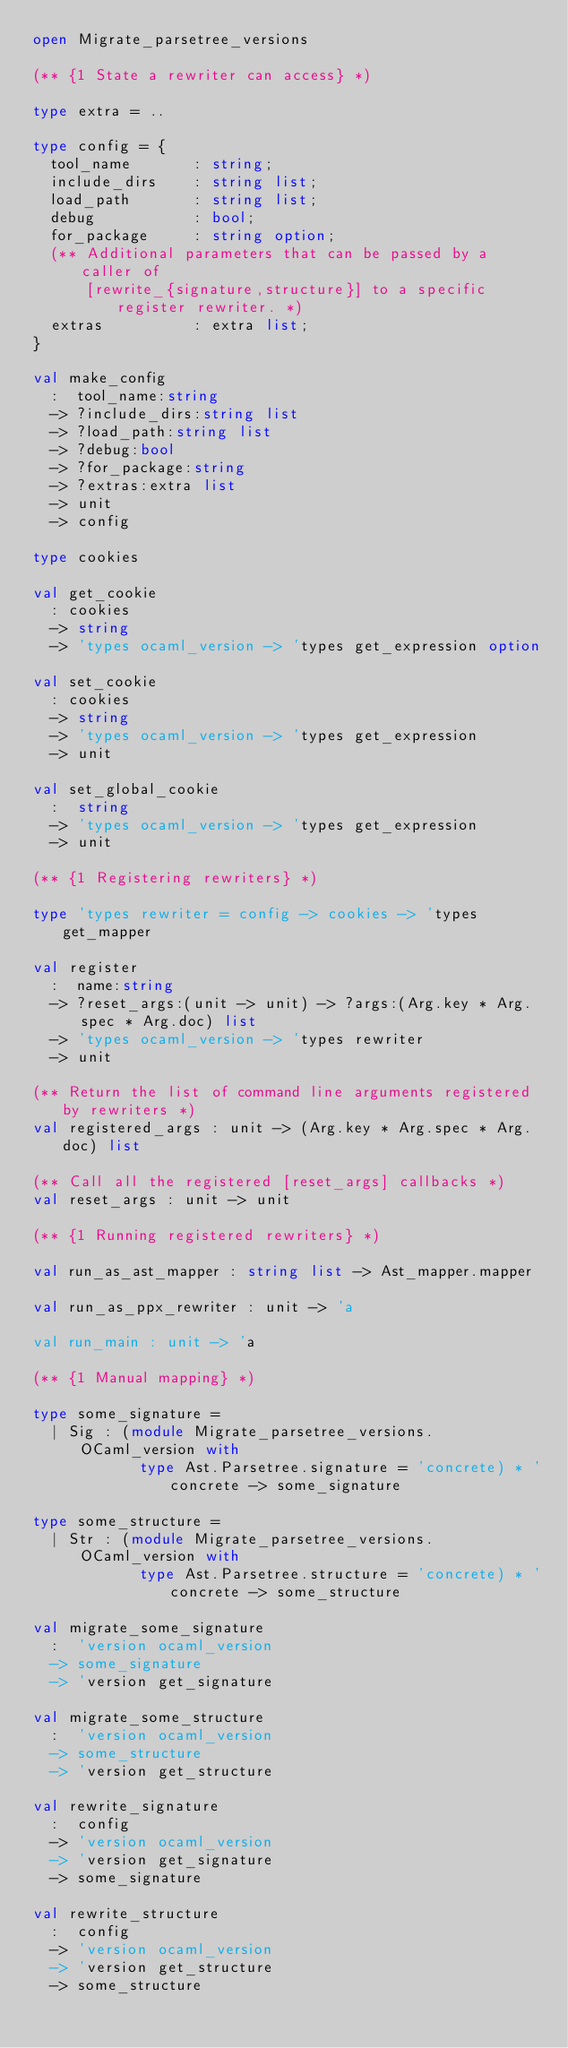Convert code to text. <code><loc_0><loc_0><loc_500><loc_500><_OCaml_>open Migrate_parsetree_versions

(** {1 State a rewriter can access} *)

type extra = ..

type config = {
  tool_name       : string;
  include_dirs    : string list;
  load_path       : string list;
  debug           : bool;
  for_package     : string option;
  (** Additional parameters that can be passed by a caller of
      [rewrite_{signature,structure}] to a specific register rewriter. *)
  extras          : extra list;
}

val make_config
  :  tool_name:string
  -> ?include_dirs:string list
  -> ?load_path:string list
  -> ?debug:bool
  -> ?for_package:string
  -> ?extras:extra list
  -> unit
  -> config

type cookies

val get_cookie
  : cookies
  -> string
  -> 'types ocaml_version -> 'types get_expression option

val set_cookie
  : cookies
  -> string
  -> 'types ocaml_version -> 'types get_expression
  -> unit

val set_global_cookie
  :  string
  -> 'types ocaml_version -> 'types get_expression
  -> unit

(** {1 Registering rewriters} *)

type 'types rewriter = config -> cookies -> 'types get_mapper

val register
  :  name:string
  -> ?reset_args:(unit -> unit) -> ?args:(Arg.key * Arg.spec * Arg.doc) list
  -> 'types ocaml_version -> 'types rewriter
  -> unit

(** Return the list of command line arguments registered by rewriters *)
val registered_args : unit -> (Arg.key * Arg.spec * Arg.doc) list

(** Call all the registered [reset_args] callbacks *)
val reset_args : unit -> unit

(** {1 Running registered rewriters} *)

val run_as_ast_mapper : string list -> Ast_mapper.mapper

val run_as_ppx_rewriter : unit -> 'a

val run_main : unit -> 'a

(** {1 Manual mapping} *)

type some_signature =
  | Sig : (module Migrate_parsetree_versions.OCaml_version with
            type Ast.Parsetree.signature = 'concrete) * 'concrete -> some_signature

type some_structure =
  | Str : (module Migrate_parsetree_versions.OCaml_version with
            type Ast.Parsetree.structure = 'concrete) * 'concrete -> some_structure

val migrate_some_signature
  :  'version ocaml_version
  -> some_signature
  -> 'version get_signature

val migrate_some_structure
  :  'version ocaml_version
  -> some_structure
  -> 'version get_structure

val rewrite_signature
  :  config
  -> 'version ocaml_version
  -> 'version get_signature
  -> some_signature

val rewrite_structure
  :  config
  -> 'version ocaml_version
  -> 'version get_structure
  -> some_structure
</code> 